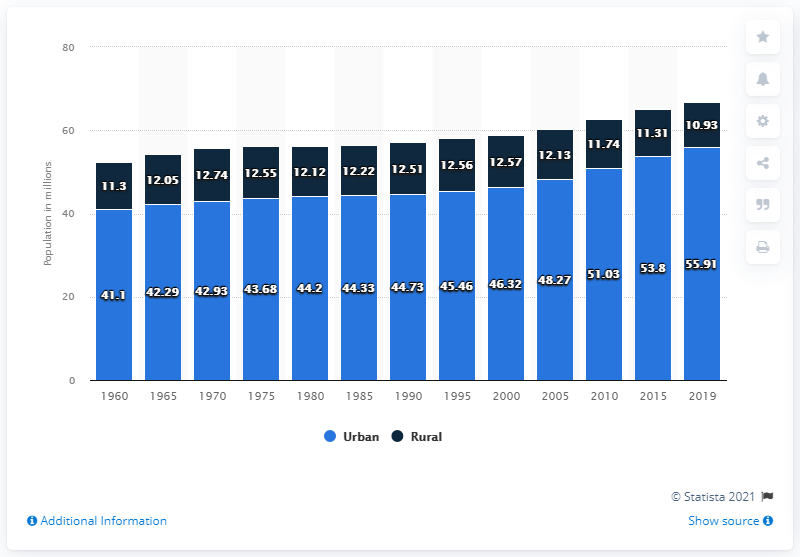Draw attention to some important aspects in this diagram. In 2019, the urban population of the UK was estimated to be 55.91%. The rural population of the United Kingdom in 2019 was approximately 10.93 million. 